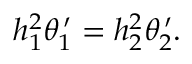Convert formula to latex. <formula><loc_0><loc_0><loc_500><loc_500>h _ { 1 } ^ { 2 } \theta _ { 1 } ^ { \, \prime } = h _ { 2 } ^ { 2 } \theta _ { 2 } ^ { \, \prime } .</formula> 